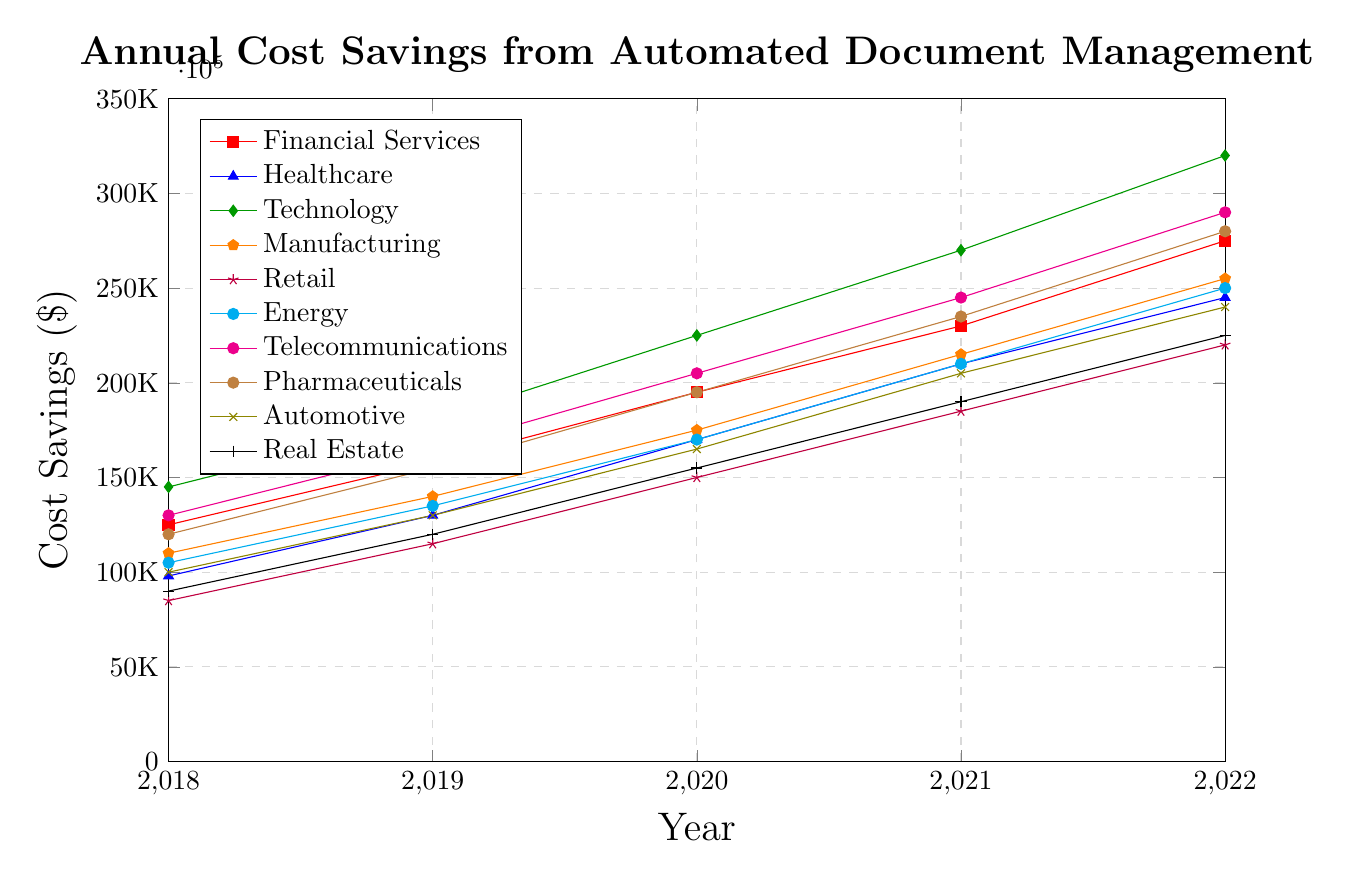What was the annual cost savings for the Technology industry in 2020? Locate the Technology line (green) and find the corresponding value for the year 2020 on the x-axis, which is 225,000.
Answer: 225,000 Which industry had the highest annual cost savings in 2022? Compare the values at the end of the line plots for the year 2022. The Technology industry (green line) has the highest value at 320,000.
Answer: Technology Between 2018 and 2022, which industry saw the greatest increase in cost savings? Calculate the difference between 2022 and 2018 values for each industry. Technology increased by 175,000 (320,000 - 145,000), which is the greatest increase.
Answer: Technology What was the combined annual cost savings for Financial Services and Healthcare in 2021? Find the value for Financial Services in 2021 which is 230,000 and Healthcare which is 210,000. Add them together 230,000 + 210,000 = 440,000.
Answer: 440,000 How does the cost savings in Retail in 2020 compare to that in Pharmaceuticals in the same year? Locate the lines for Retail (orange) and Pharmaceuticals (purple) for the year 2020. Retail has 150,000 and Pharmaceuticals have 195,000, so Retail is 45,000 less than Pharmaceuticals.
Answer: Retail is 45,000 less What is the average annual cost savings for the Manufacturing industry over the entire period? Sum the values for Manufacturing (110,000, 140,000, 175,000, 215,000, 255,000) and divide by the number of years (5). (110,000 + 140,000 + 175,000 + 215,000 + 255,000) / 5 = 179,000.
Answer: 179,000 Which industry shows a steady increase in annual cost savings every year from 2018 to 2022? Check each line to see which one increases every year without any drops. Telecommunications (magenta) increases consistently each year.
Answer: Telecommunications Is the annual cost savings in Financial Services in 2020 greater than in Energy in 2021? Compare the values for Financial Services in 2020 (195,000) and Energy in 2021 (210,000). Energy in 2021 is greater.
Answer: No Among the listed years, how many times did the Healthcare industry have more cost savings than the Real Estate industry? Compare Healthcare and Real Estate cost savings for each year. Healthcare had more savings in all five years (2018, 2019, 2020, 2021, 2022).
Answer: 5 